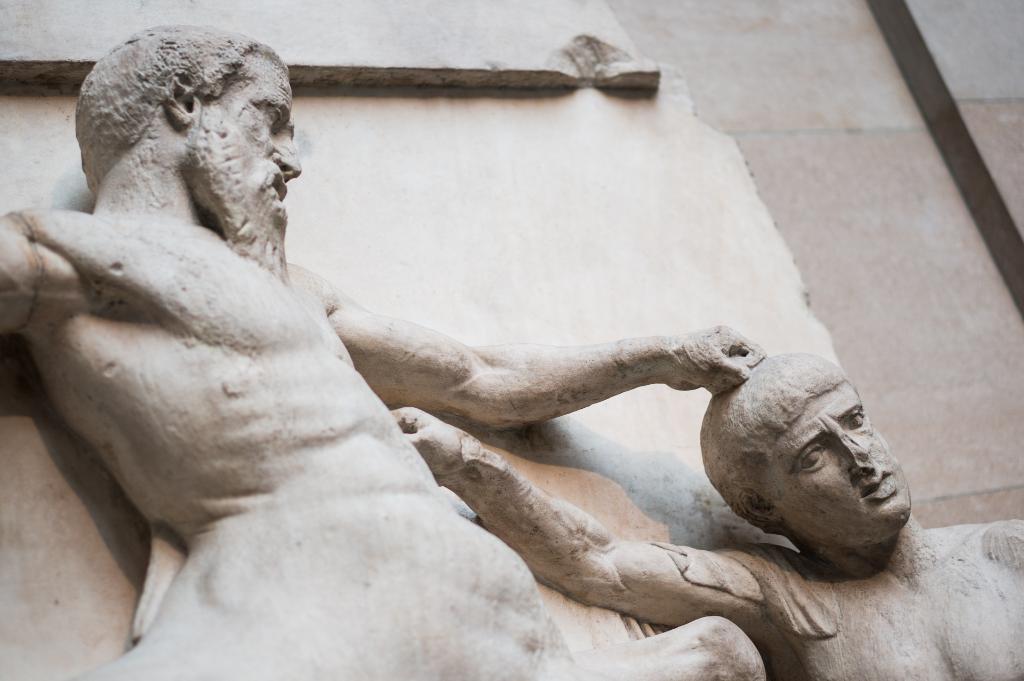Can you describe this image briefly? In this picture we can see statues. In the background of the image we can see wall. 